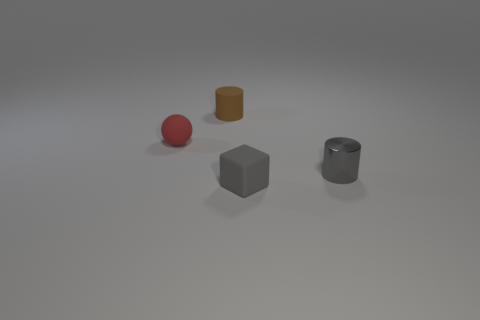Is the shape of the gray rubber object the same as the thing behind the small red thing?
Ensure brevity in your answer.  No. What is the color of the rubber object that is on the right side of the cylinder behind the small cylinder that is in front of the small red rubber ball?
Offer a terse response. Gray. How many objects are either rubber objects that are behind the tiny metal cylinder or matte objects behind the tiny red thing?
Ensure brevity in your answer.  2. What number of other objects are the same color as the small metal thing?
Give a very brief answer. 1. There is a matte thing to the left of the tiny brown object; is it the same shape as the tiny brown thing?
Your response must be concise. No. Are there fewer brown cylinders in front of the red sphere than tiny red balls?
Give a very brief answer. Yes. Is there a gray object made of the same material as the small red thing?
Ensure brevity in your answer.  Yes. What material is the brown cylinder that is the same size as the red ball?
Ensure brevity in your answer.  Rubber. Is the number of tiny rubber objects that are on the right side of the gray rubber block less than the number of gray objects on the left side of the small shiny cylinder?
Offer a very short reply. Yes. There is a rubber object that is right of the small red object and in front of the brown matte cylinder; what is its shape?
Offer a very short reply. Cube. 